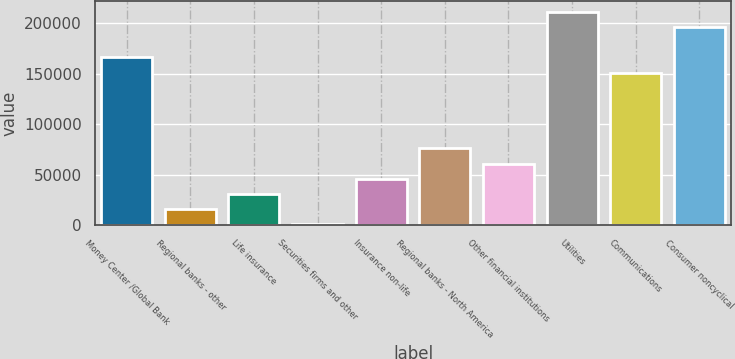Convert chart. <chart><loc_0><loc_0><loc_500><loc_500><bar_chart><fcel>Money Center /Global Bank<fcel>Regional banks - other<fcel>Life insurance<fcel>Securities firms and other<fcel>Insurance non-life<fcel>Regional banks - North America<fcel>Other financial institutions<fcel>Utilities<fcel>Communications<fcel>Consumer noncyclical<nl><fcel>166160<fcel>15683.6<fcel>30731.2<fcel>636<fcel>45778.8<fcel>75874<fcel>60826.4<fcel>211302<fcel>151112<fcel>196255<nl></chart> 